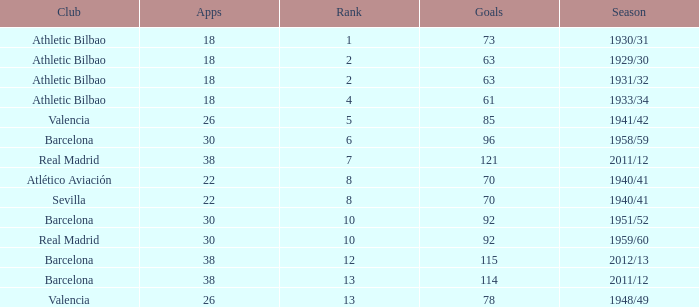What season was Barcelona ranked higher than 12, had more than 96 goals and had more than 26 apps? 2011/12. 